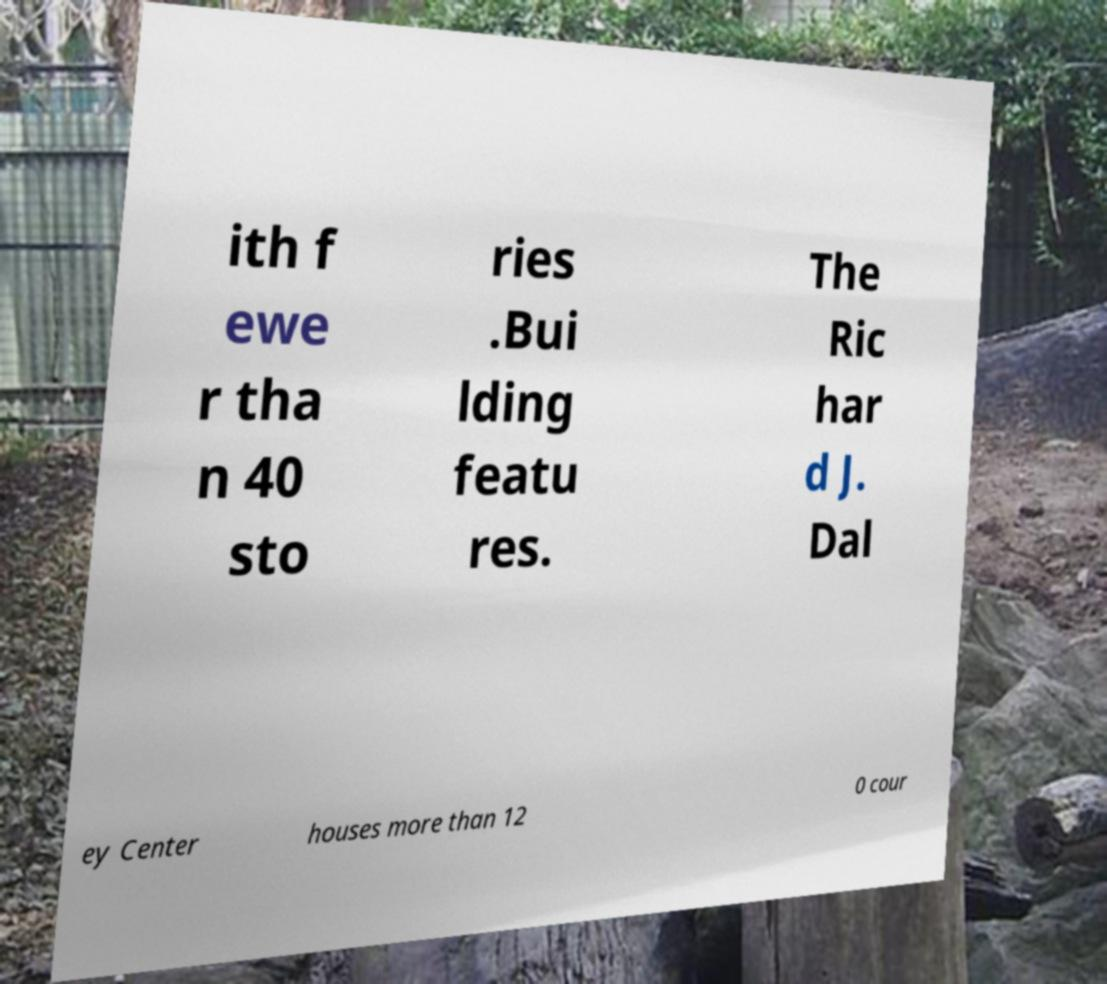There's text embedded in this image that I need extracted. Can you transcribe it verbatim? ith f ewe r tha n 40 sto ries .Bui lding featu res. The Ric har d J. Dal ey Center houses more than 12 0 cour 